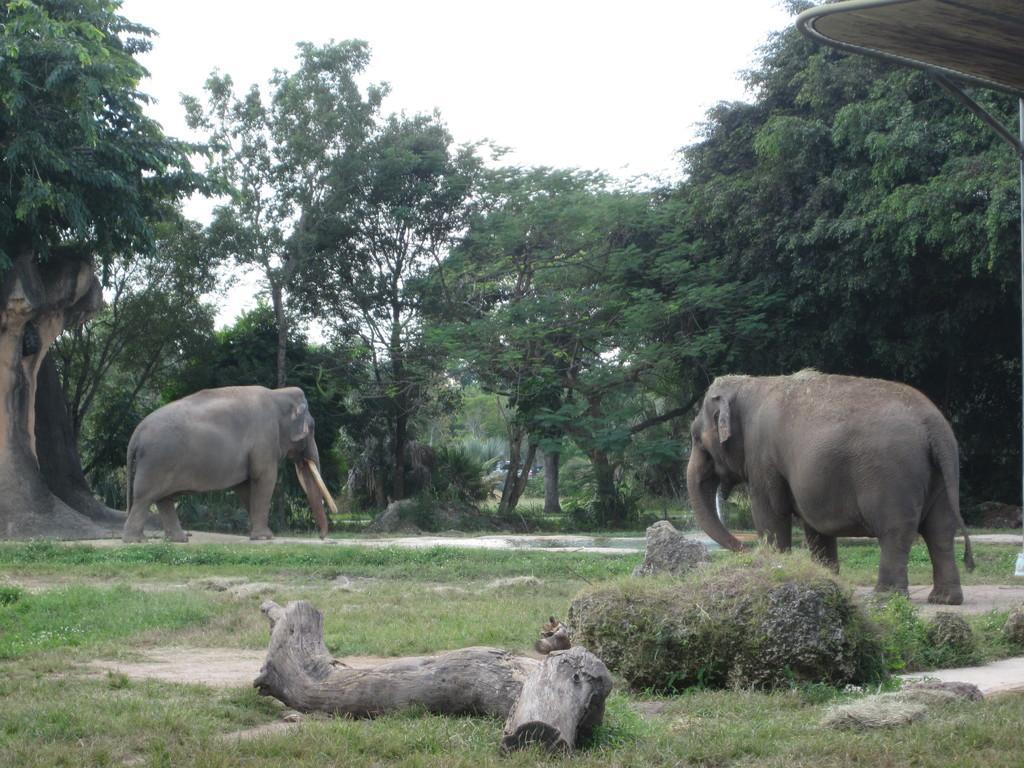Could you give a brief overview of what you see in this image? In this image we can see two elephants standing on the ground. In the foreground we can see wood log. In the background, we can see a shed and the sky. 